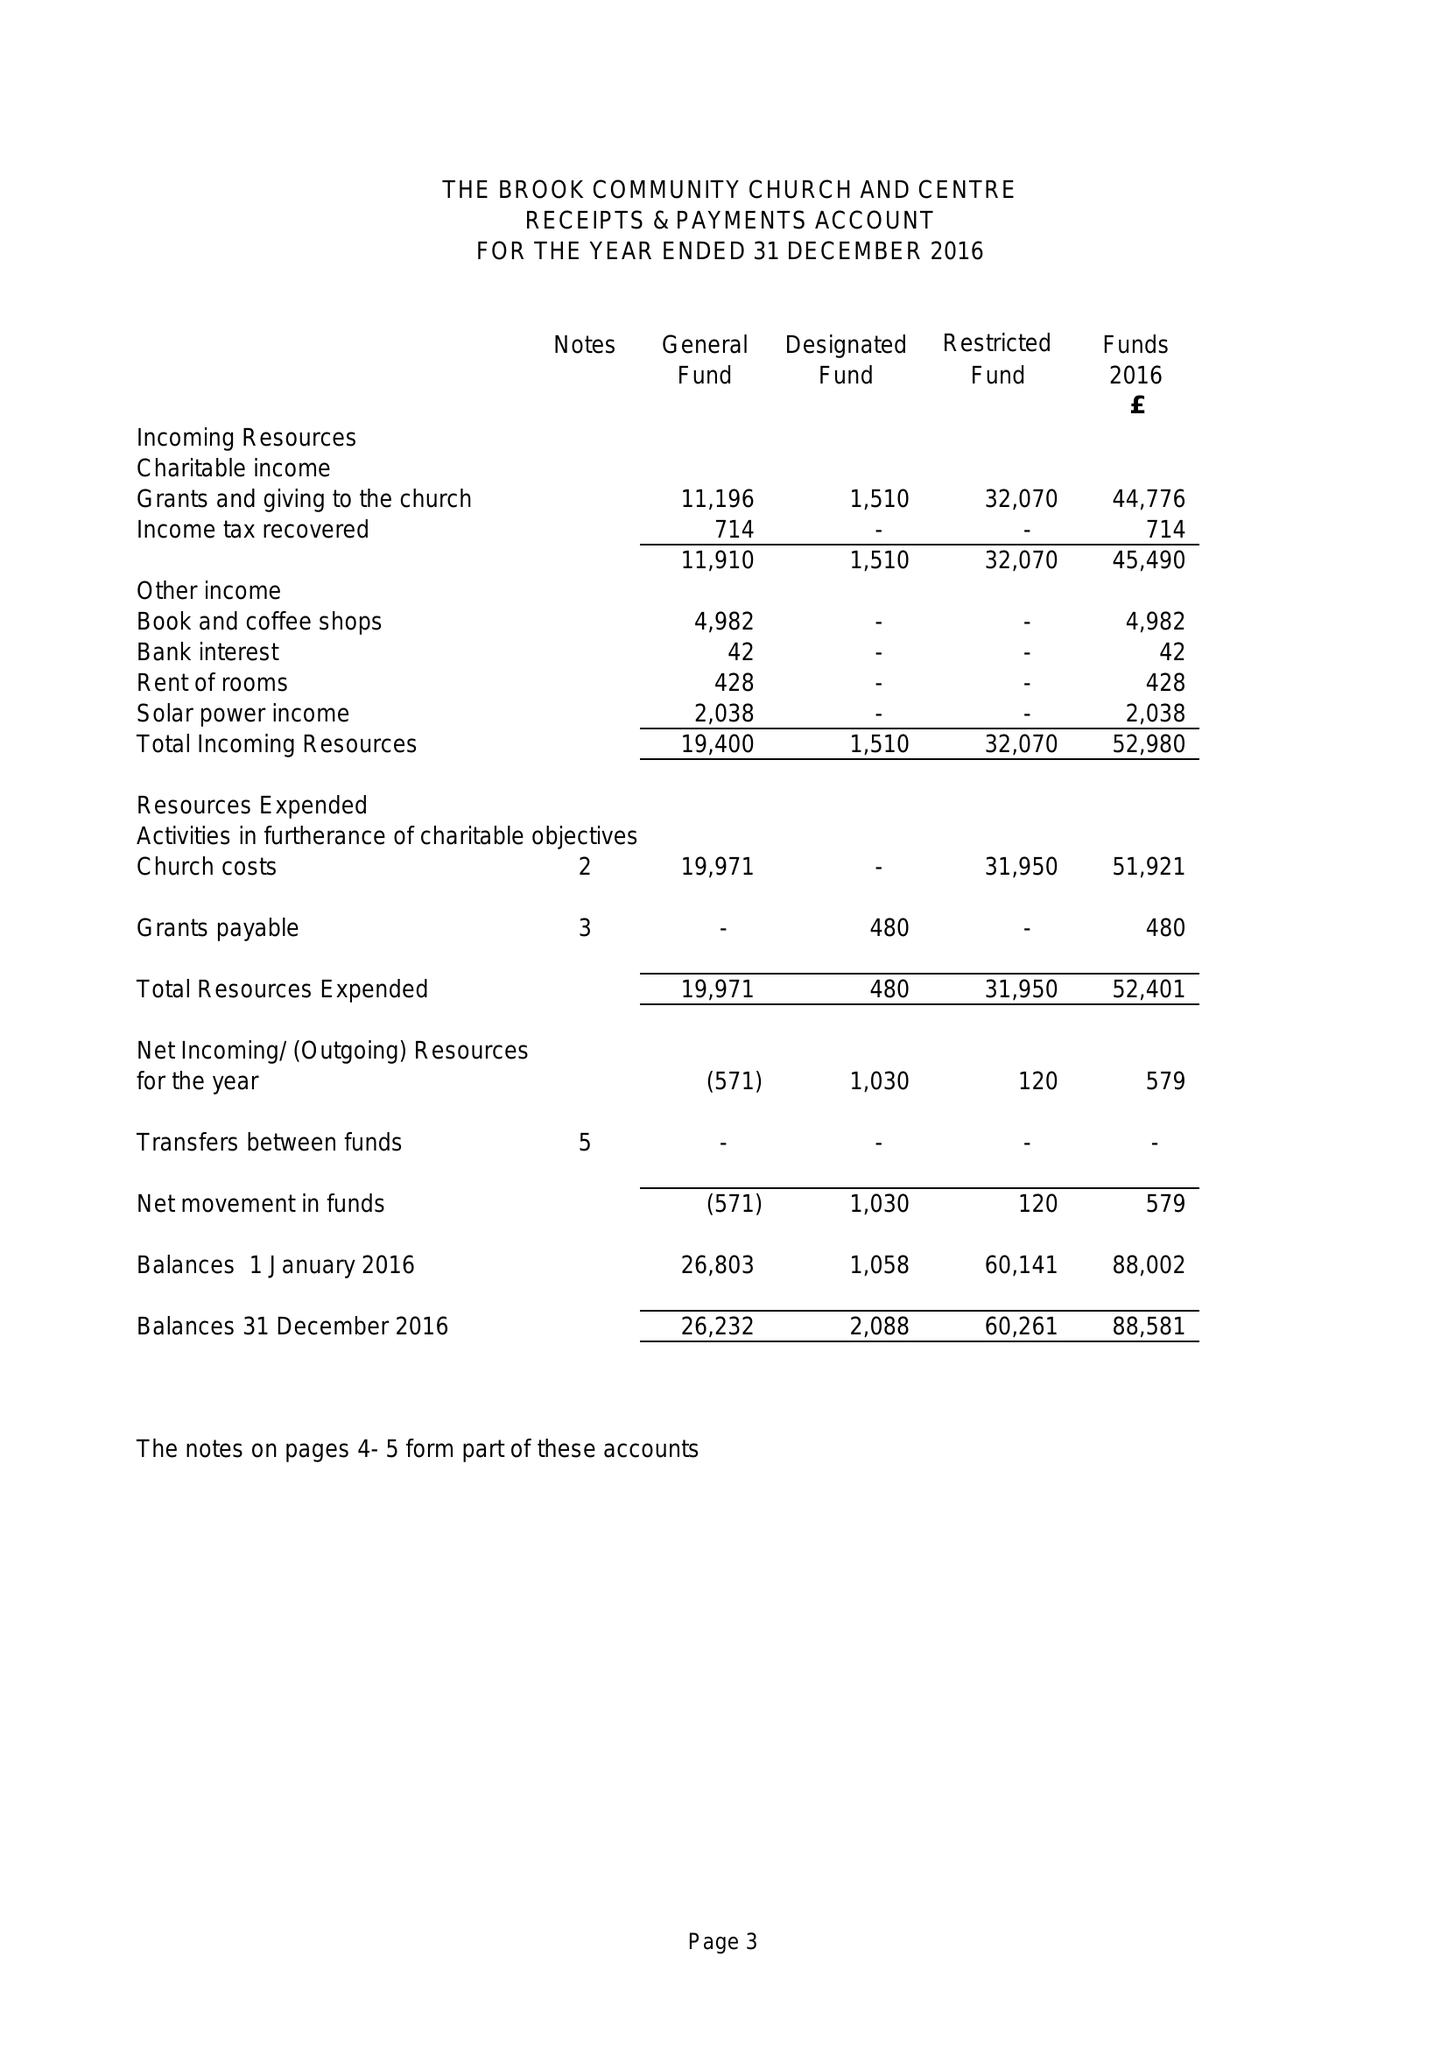What is the value for the address__post_town?
Answer the question using a single word or phrase. MANSFIELD 